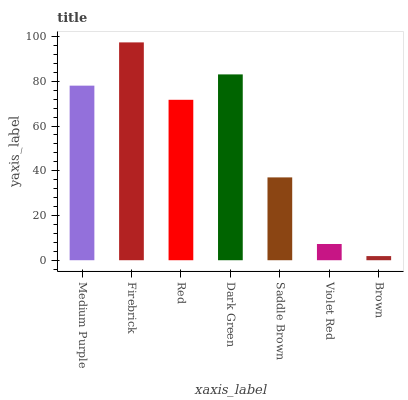Is Brown the minimum?
Answer yes or no. Yes. Is Firebrick the maximum?
Answer yes or no. Yes. Is Red the minimum?
Answer yes or no. No. Is Red the maximum?
Answer yes or no. No. Is Firebrick greater than Red?
Answer yes or no. Yes. Is Red less than Firebrick?
Answer yes or no. Yes. Is Red greater than Firebrick?
Answer yes or no. No. Is Firebrick less than Red?
Answer yes or no. No. Is Red the high median?
Answer yes or no. Yes. Is Red the low median?
Answer yes or no. Yes. Is Brown the high median?
Answer yes or no. No. Is Brown the low median?
Answer yes or no. No. 